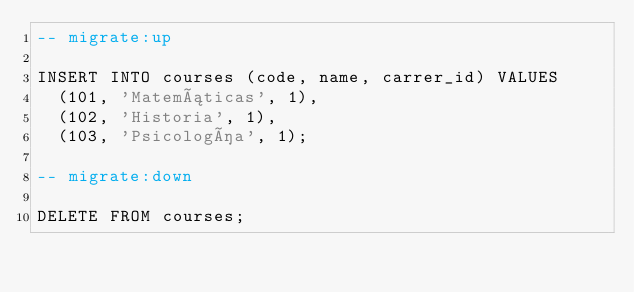<code> <loc_0><loc_0><loc_500><loc_500><_SQL_>-- migrate:up

INSERT INTO courses (code, name, carrer_id) VALUES
  (101, 'Matemáticas', 1),
  (102, 'Historia', 1),
  (103, 'Psicología', 1);

-- migrate:down

DELETE FROM courses;</code> 